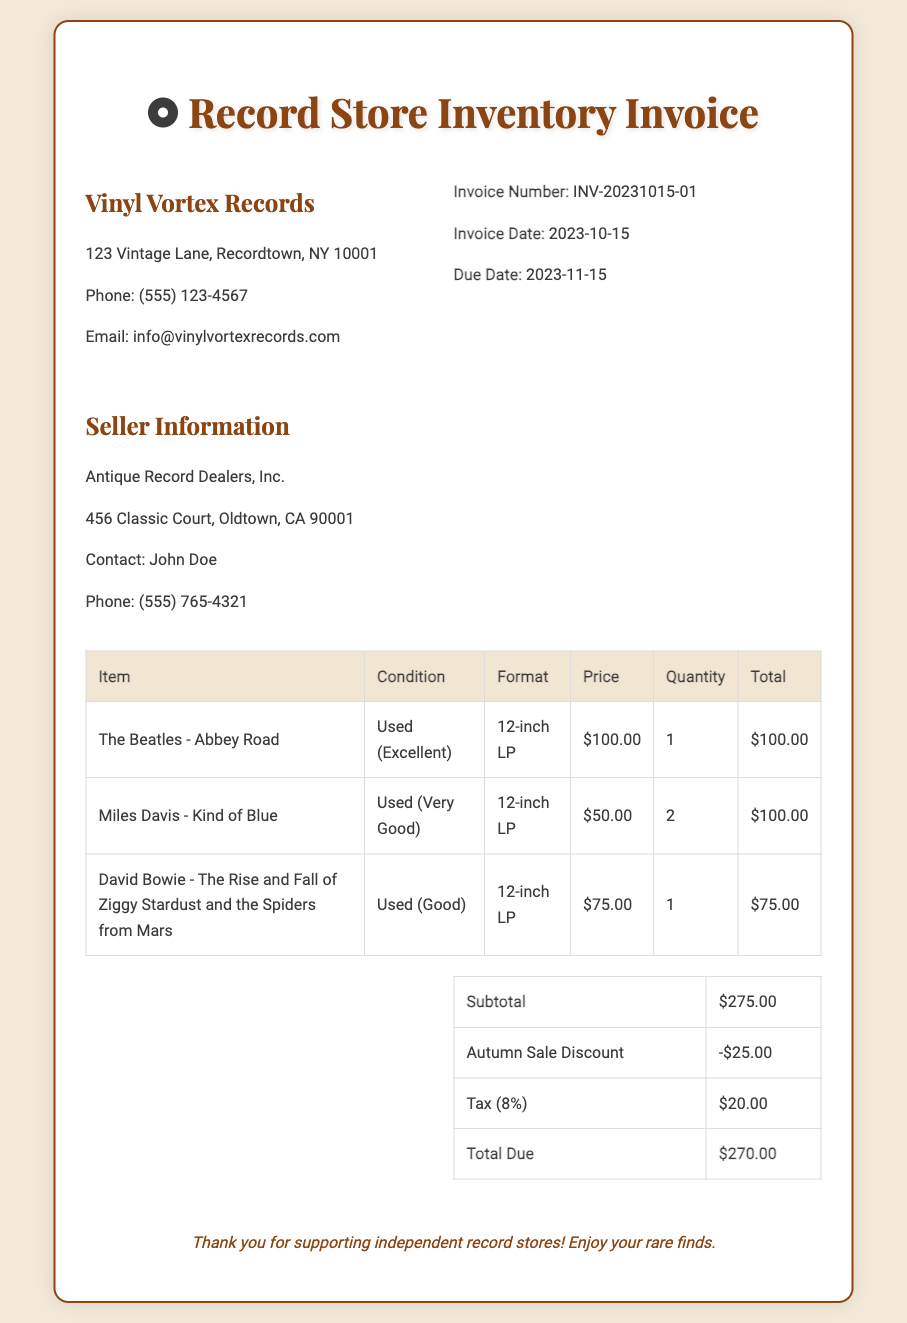What is the invoice number? The invoice number is specified in the header of the document.
Answer: INV-20231015-01 Who is the seller? The seller information is provided in a separate section of the document.
Answer: Antique Record Dealers, Inc What is the due date for the invoice? The due date is noted in the header along with other invoice details.
Answer: 2023-11-15 How many records did Miles Davis - Kind of Blue sell? The quantity sold is listed in the table for that specific record.
Answer: 2 What is the subtotal amount before discounts and taxes? The subtotal is listed in the summary table at the bottom of the invoice.
Answer: $275.00 What is the final total due after applying the discount and taxes? The total due is calculated after applying any discounts and taxes as shown in the summary.
Answer: $270.00 What kind of vinyl format is listed for David Bowie’s record? The format is specified in the table under the format column.
Answer: 12-inch LP What discount was applied? The discount amount is provided in the summary table of the invoice.
Answer: -$25.00 What is the tax rate applied to the invoice? The tax amount applied is based on the subtotal, so we infer the rate.
Answer: 8% 